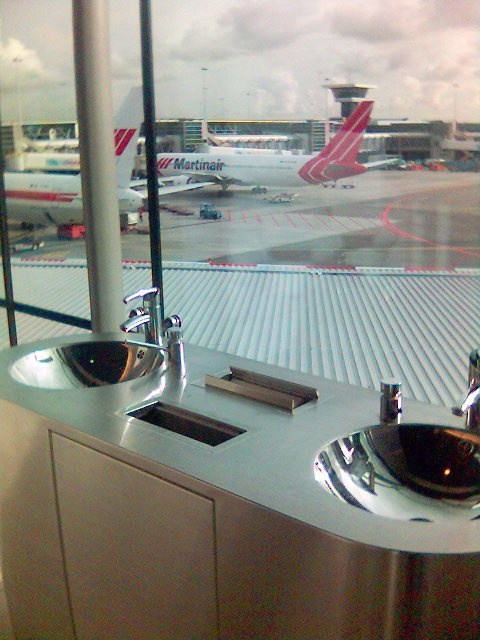Describe the objects in this image and their specific colors. I can see sink in darkgray, black, gray, and lightgray tones, airplane in darkgray, brown, lightblue, and gray tones, airplane in darkgray, gray, and brown tones, sink in darkgray, black, ivory, and gray tones, and truck in darkgray, blue, gray, and teal tones in this image. 